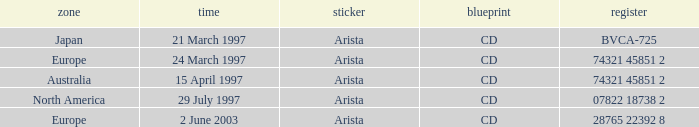What is the label assigned to the region of australia? Arista. 